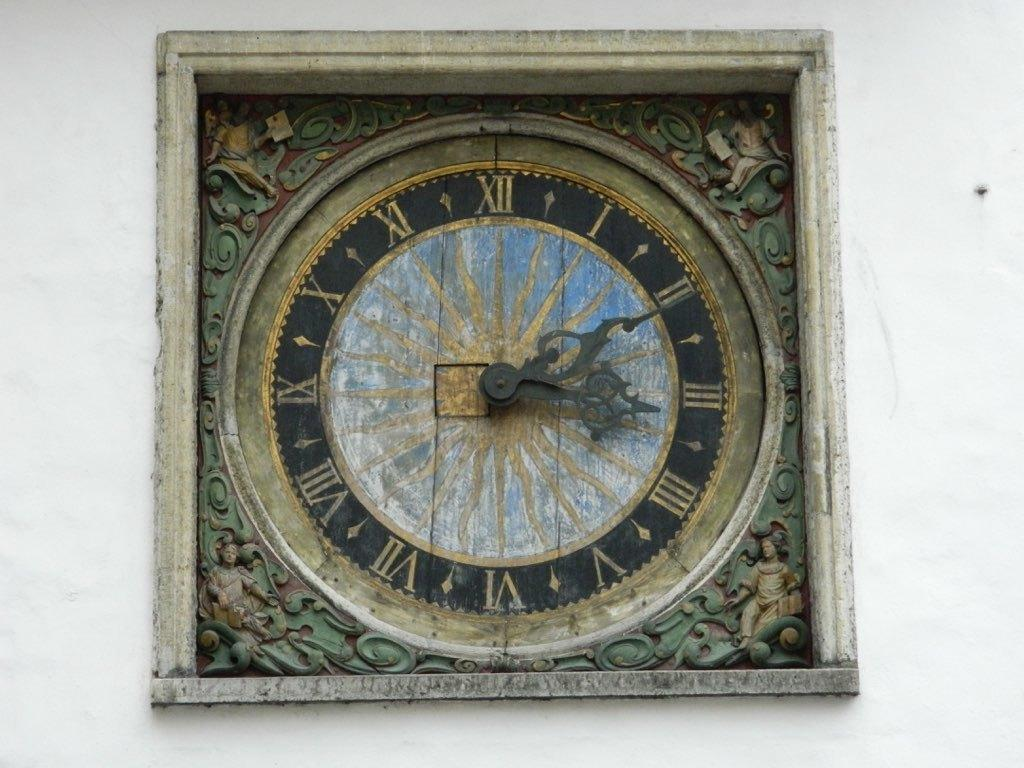<image>
Write a terse but informative summary of the picture. antique clock that has one hand on the number 2 and the other on number 3. 